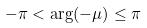<formula> <loc_0><loc_0><loc_500><loc_500>- \pi < \arg ( - \mu ) \leq \pi</formula> 